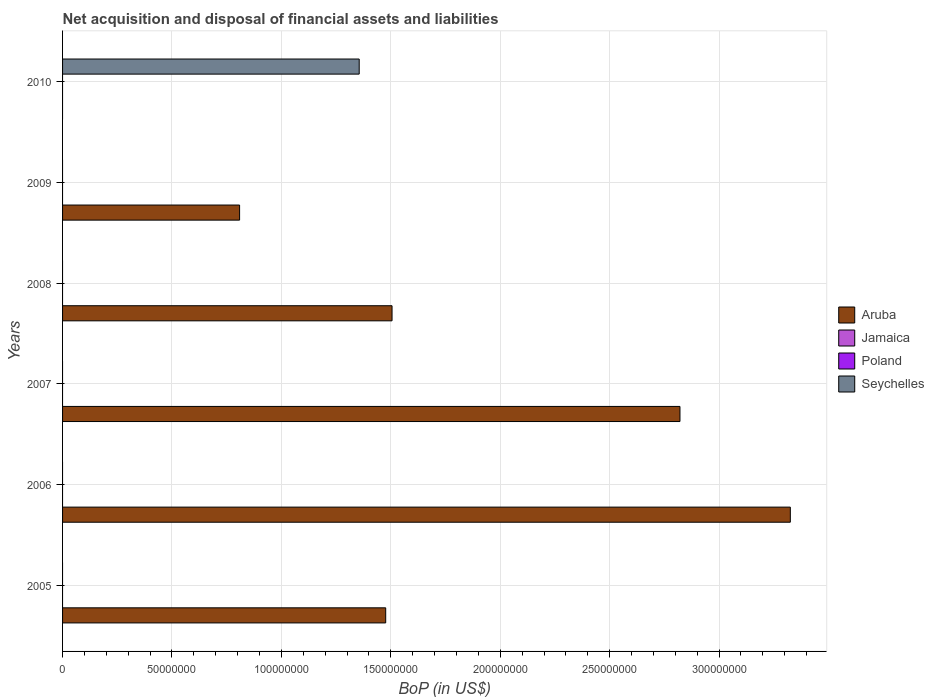How many bars are there on the 5th tick from the top?
Your response must be concise. 1. What is the label of the 3rd group of bars from the top?
Provide a short and direct response. 2008. Across all years, what is the maximum Balance of Payments in Aruba?
Your answer should be very brief. 3.33e+08. Across all years, what is the minimum Balance of Payments in Jamaica?
Your response must be concise. 0. In which year was the Balance of Payments in Aruba maximum?
Your answer should be compact. 2006. What is the difference between the Balance of Payments in Aruba in 2008 and that in 2009?
Provide a short and direct response. 6.97e+07. What is the difference between the Balance of Payments in Seychelles in 2010 and the Balance of Payments in Poland in 2008?
Ensure brevity in your answer.  1.36e+08. What is the ratio of the Balance of Payments in Aruba in 2006 to that in 2009?
Provide a short and direct response. 4.11. What is the difference between the highest and the second highest Balance of Payments in Aruba?
Give a very brief answer. 5.04e+07. What is the difference between the highest and the lowest Balance of Payments in Seychelles?
Give a very brief answer. 1.36e+08. How many bars are there?
Your answer should be compact. 6. What is the difference between two consecutive major ticks on the X-axis?
Provide a succinct answer. 5.00e+07. Does the graph contain grids?
Provide a short and direct response. Yes. How are the legend labels stacked?
Your answer should be compact. Vertical. What is the title of the graph?
Ensure brevity in your answer.  Net acquisition and disposal of financial assets and liabilities. What is the label or title of the X-axis?
Provide a short and direct response. BoP (in US$). What is the label or title of the Y-axis?
Keep it short and to the point. Years. What is the BoP (in US$) of Aruba in 2005?
Ensure brevity in your answer.  1.48e+08. What is the BoP (in US$) of Jamaica in 2005?
Your answer should be very brief. 0. What is the BoP (in US$) in Seychelles in 2005?
Offer a very short reply. 0. What is the BoP (in US$) in Aruba in 2006?
Your answer should be very brief. 3.33e+08. What is the BoP (in US$) of Jamaica in 2006?
Provide a succinct answer. 0. What is the BoP (in US$) of Seychelles in 2006?
Give a very brief answer. 0. What is the BoP (in US$) in Aruba in 2007?
Your answer should be very brief. 2.82e+08. What is the BoP (in US$) of Poland in 2007?
Keep it short and to the point. 0. What is the BoP (in US$) in Seychelles in 2007?
Give a very brief answer. 0. What is the BoP (in US$) in Aruba in 2008?
Give a very brief answer. 1.51e+08. What is the BoP (in US$) in Poland in 2008?
Make the answer very short. 0. What is the BoP (in US$) of Seychelles in 2008?
Your answer should be compact. 0. What is the BoP (in US$) of Aruba in 2009?
Offer a terse response. 8.09e+07. What is the BoP (in US$) of Poland in 2009?
Provide a short and direct response. 0. What is the BoP (in US$) of Seychelles in 2009?
Provide a succinct answer. 0. What is the BoP (in US$) in Seychelles in 2010?
Keep it short and to the point. 1.36e+08. Across all years, what is the maximum BoP (in US$) of Aruba?
Your answer should be compact. 3.33e+08. Across all years, what is the maximum BoP (in US$) in Seychelles?
Keep it short and to the point. 1.36e+08. Across all years, what is the minimum BoP (in US$) of Seychelles?
Your response must be concise. 0. What is the total BoP (in US$) in Aruba in the graph?
Offer a terse response. 9.94e+08. What is the total BoP (in US$) in Jamaica in the graph?
Provide a succinct answer. 0. What is the total BoP (in US$) in Poland in the graph?
Offer a terse response. 0. What is the total BoP (in US$) in Seychelles in the graph?
Provide a short and direct response. 1.36e+08. What is the difference between the BoP (in US$) in Aruba in 2005 and that in 2006?
Your response must be concise. -1.85e+08. What is the difference between the BoP (in US$) in Aruba in 2005 and that in 2007?
Provide a succinct answer. -1.34e+08. What is the difference between the BoP (in US$) in Aruba in 2005 and that in 2008?
Provide a short and direct response. -2.90e+06. What is the difference between the BoP (in US$) of Aruba in 2005 and that in 2009?
Provide a short and direct response. 6.68e+07. What is the difference between the BoP (in US$) in Aruba in 2006 and that in 2007?
Provide a short and direct response. 5.04e+07. What is the difference between the BoP (in US$) of Aruba in 2006 and that in 2008?
Keep it short and to the point. 1.82e+08. What is the difference between the BoP (in US$) of Aruba in 2006 and that in 2009?
Your answer should be compact. 2.52e+08. What is the difference between the BoP (in US$) in Aruba in 2007 and that in 2008?
Give a very brief answer. 1.32e+08. What is the difference between the BoP (in US$) of Aruba in 2007 and that in 2009?
Your answer should be very brief. 2.01e+08. What is the difference between the BoP (in US$) in Aruba in 2008 and that in 2009?
Keep it short and to the point. 6.97e+07. What is the difference between the BoP (in US$) of Aruba in 2005 and the BoP (in US$) of Seychelles in 2010?
Your answer should be very brief. 1.21e+07. What is the difference between the BoP (in US$) of Aruba in 2006 and the BoP (in US$) of Seychelles in 2010?
Provide a short and direct response. 1.97e+08. What is the difference between the BoP (in US$) in Aruba in 2007 and the BoP (in US$) in Seychelles in 2010?
Provide a short and direct response. 1.47e+08. What is the difference between the BoP (in US$) in Aruba in 2008 and the BoP (in US$) in Seychelles in 2010?
Your answer should be very brief. 1.50e+07. What is the difference between the BoP (in US$) in Aruba in 2009 and the BoP (in US$) in Seychelles in 2010?
Give a very brief answer. -5.47e+07. What is the average BoP (in US$) in Aruba per year?
Your answer should be compact. 1.66e+08. What is the average BoP (in US$) in Jamaica per year?
Keep it short and to the point. 0. What is the average BoP (in US$) in Seychelles per year?
Your response must be concise. 2.26e+07. What is the ratio of the BoP (in US$) of Aruba in 2005 to that in 2006?
Give a very brief answer. 0.44. What is the ratio of the BoP (in US$) of Aruba in 2005 to that in 2007?
Give a very brief answer. 0.52. What is the ratio of the BoP (in US$) in Aruba in 2005 to that in 2008?
Offer a terse response. 0.98. What is the ratio of the BoP (in US$) in Aruba in 2005 to that in 2009?
Keep it short and to the point. 1.83. What is the ratio of the BoP (in US$) of Aruba in 2006 to that in 2007?
Keep it short and to the point. 1.18. What is the ratio of the BoP (in US$) of Aruba in 2006 to that in 2008?
Give a very brief answer. 2.21. What is the ratio of the BoP (in US$) in Aruba in 2006 to that in 2009?
Your answer should be compact. 4.11. What is the ratio of the BoP (in US$) in Aruba in 2007 to that in 2008?
Offer a terse response. 1.87. What is the ratio of the BoP (in US$) of Aruba in 2007 to that in 2009?
Offer a very short reply. 3.49. What is the ratio of the BoP (in US$) in Aruba in 2008 to that in 2009?
Your answer should be very brief. 1.86. What is the difference between the highest and the second highest BoP (in US$) of Aruba?
Offer a very short reply. 5.04e+07. What is the difference between the highest and the lowest BoP (in US$) in Aruba?
Offer a very short reply. 3.33e+08. What is the difference between the highest and the lowest BoP (in US$) in Seychelles?
Provide a succinct answer. 1.36e+08. 